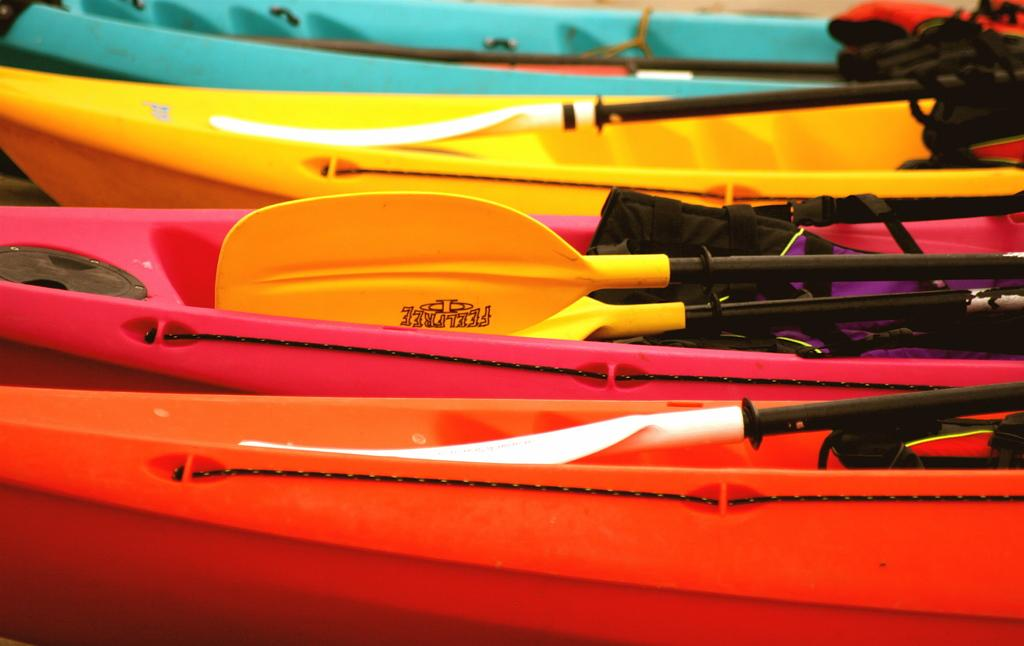What is the main subject of the image? The main subject of the image is a group of boats. What can be found inside the boats? The boats contain bags. What feature do the boats have? The boats have rows in them. What type of iron can be seen in the image? There is no iron present in the image. Can you see any bees flying around the boats in the image? There are no bees present in the image. 